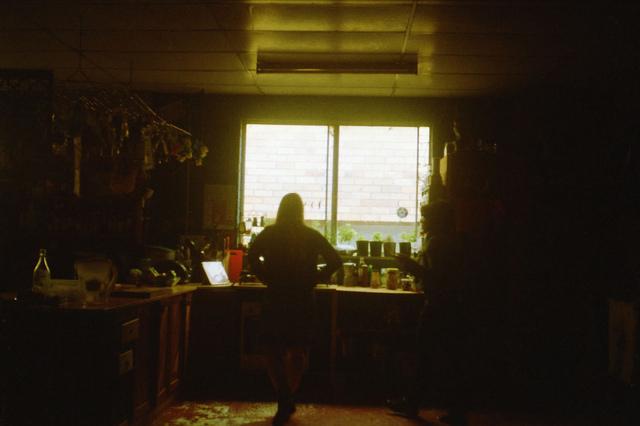What is the girl playing?
Quick response, please. Cooking. How tall are the ceilings?
Quick response, please. 8 feet. Is this a large family?
Quick response, please. No. The lights of this place are on?
Quick response, please. No. How many people do you see?
Concise answer only. 1. What room is this?
Quick response, please. Kitchen. Is the hallway wide or narrow?
Give a very brief answer. Wide. What type of stove is this?
Short answer required. Electric. Is this romantic?
Answer briefly. No. Is there anyone in this room?
Write a very short answer. Yes. Why is the room so dark?
Give a very brief answer. No lights. Are there any lights on?
Answer briefly. No. Is the lights on?
Write a very short answer. No. Could this be a restaurant?
Short answer required. No. Is this a restaurant?
Short answer required. No. Is the man looking at the camera?
Short answer required. No. Was this photo taken in a home?
Write a very short answer. Yes. Why is this room so dark?
Write a very short answer. No lights. Is it daytime?
Quick response, please. Yes. Is it raining?
Quick response, please. No. Does the person have their feet on the ground?
Short answer required. Yes. Is this place lit up?
Concise answer only. No. Are they watching TV?
Be succinct. No. Are there any lights on in the room?
Give a very brief answer. No. 